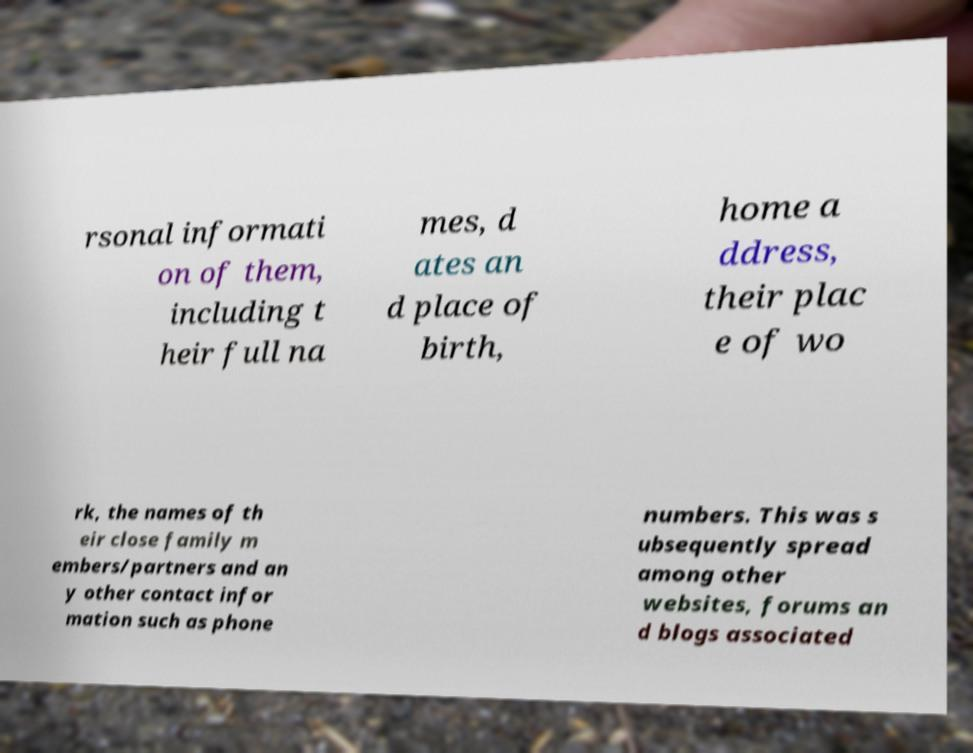There's text embedded in this image that I need extracted. Can you transcribe it verbatim? rsonal informati on of them, including t heir full na mes, d ates an d place of birth, home a ddress, their plac e of wo rk, the names of th eir close family m embers/partners and an y other contact infor mation such as phone numbers. This was s ubsequently spread among other websites, forums an d blogs associated 